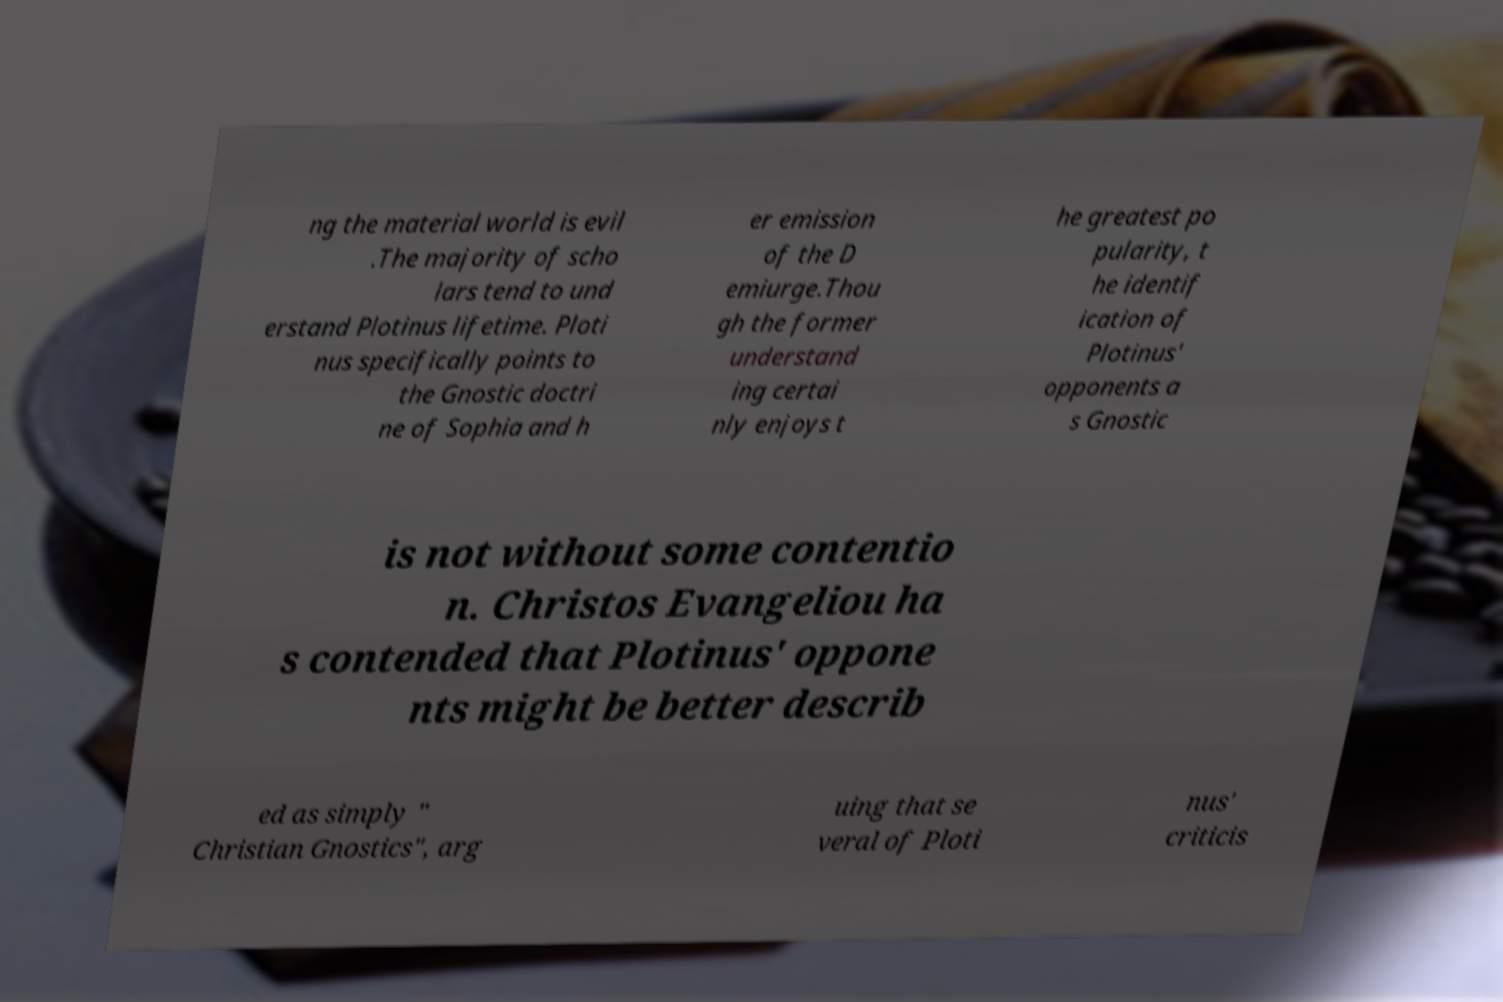Please read and relay the text visible in this image. What does it say? ng the material world is evil .The majority of scho lars tend to und erstand Plotinus lifetime. Ploti nus specifically points to the Gnostic doctri ne of Sophia and h er emission of the D emiurge.Thou gh the former understand ing certai nly enjoys t he greatest po pularity, t he identif ication of Plotinus' opponents a s Gnostic is not without some contentio n. Christos Evangeliou ha s contended that Plotinus' oppone nts might be better describ ed as simply " Christian Gnostics", arg uing that se veral of Ploti nus' criticis 